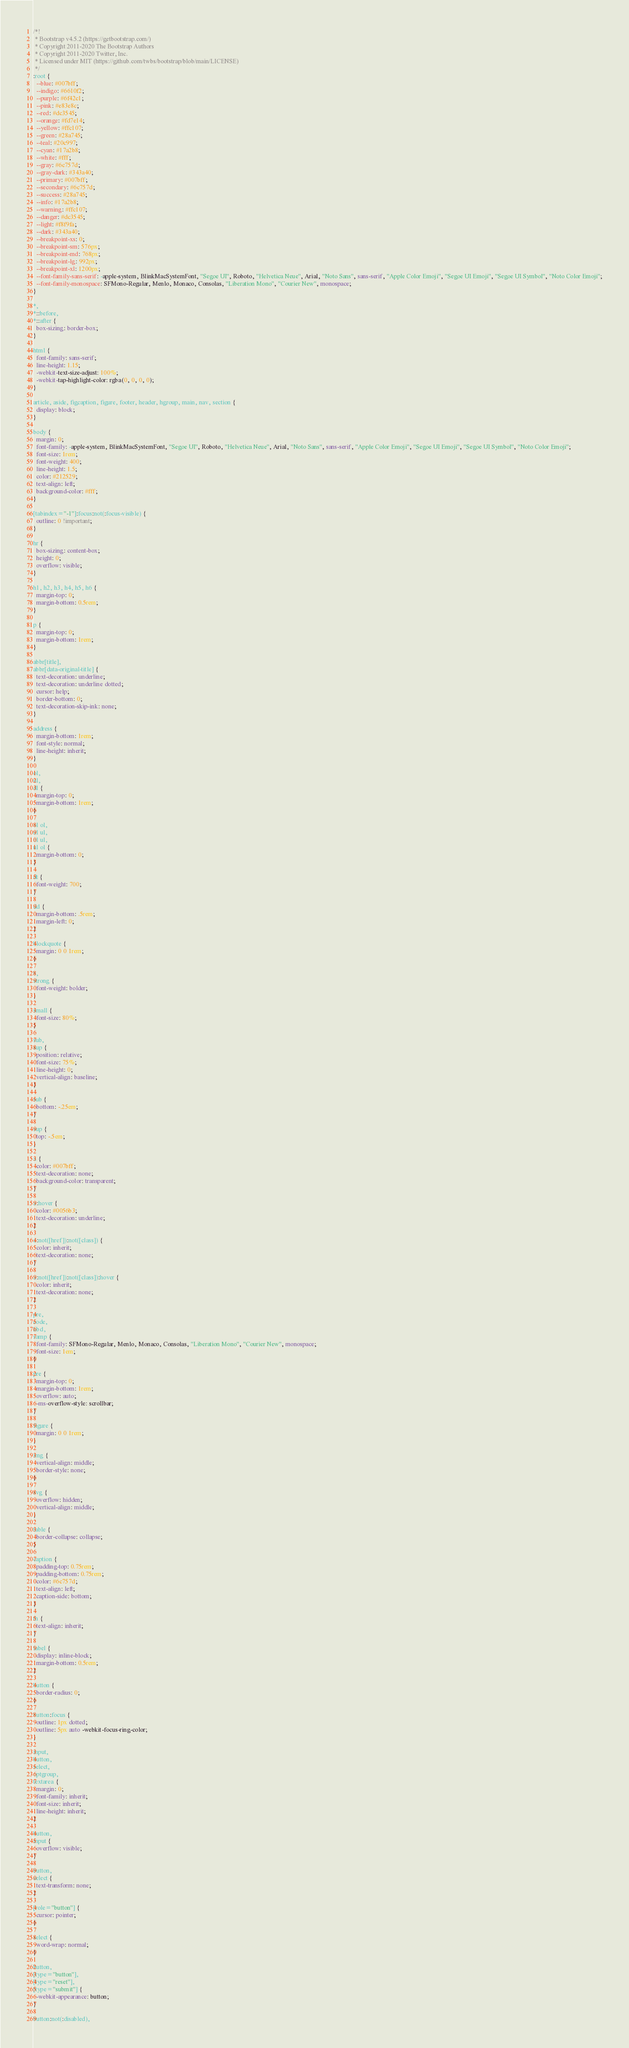<code> <loc_0><loc_0><loc_500><loc_500><_CSS_>/*!
 * Bootstrap v4.5.2 (https://getbootstrap.com/)
 * Copyright 2011-2020 The Bootstrap Authors
 * Copyright 2011-2020 Twitter, Inc.
 * Licensed under MIT (https://github.com/twbs/bootstrap/blob/main/LICENSE)
 */
:root {
  --blue: #007bff;
  --indigo: #6610f2;
  --purple: #6f42c1;
  --pink: #e83e8c;
  --red: #dc3545;
  --orange: #fd7e14;
  --yellow: #ffc107;
  --green: #28a745;
  --teal: #20c997;
  --cyan: #17a2b8;
  --white: #fff;
  --gray: #6c757d;
  --gray-dark: #343a40;
  --primary: #007bff;
  --secondary: #6c757d;
  --success: #28a745;
  --info: #17a2b8;
  --warning: #ffc107;
  --danger: #dc3545;
  --light: #f8f9fa;
  --dark: #343a40;
  --breakpoint-xs: 0;
  --breakpoint-sm: 576px;
  --breakpoint-md: 768px;
  --breakpoint-lg: 992px;
  --breakpoint-xl: 1200px;
  --font-family-sans-serif: -apple-system, BlinkMacSystemFont, "Segoe UI", Roboto, "Helvetica Neue", Arial, "Noto Sans", sans-serif, "Apple Color Emoji", "Segoe UI Emoji", "Segoe UI Symbol", "Noto Color Emoji";
  --font-family-monospace: SFMono-Regular, Menlo, Monaco, Consolas, "Liberation Mono", "Courier New", monospace;
}

*,
*::before,
*::after {
  box-sizing: border-box;
}

html {
  font-family: sans-serif;
  line-height: 1.15;
  -webkit-text-size-adjust: 100%;
  -webkit-tap-highlight-color: rgba(0, 0, 0, 0);
}

article, aside, figcaption, figure, footer, header, hgroup, main, nav, section {
  display: block;
}

body {
  margin: 0;
  font-family: -apple-system, BlinkMacSystemFont, "Segoe UI", Roboto, "Helvetica Neue", Arial, "Noto Sans", sans-serif, "Apple Color Emoji", "Segoe UI Emoji", "Segoe UI Symbol", "Noto Color Emoji";
  font-size: 1rem;
  font-weight: 400;
  line-height: 1.5;
  color: #212529;
  text-align: left;
  background-color: #fff;
}

[tabindex="-1"]:focus:not(:focus-visible) {
  outline: 0 !important;
}

hr {
  box-sizing: content-box;
  height: 0;
  overflow: visible;
}

h1, h2, h3, h4, h5, h6 {
  margin-top: 0;
  margin-bottom: 0.5rem;
}

p {
  margin-top: 0;
  margin-bottom: 1rem;
}

abbr[title],
abbr[data-original-title] {
  text-decoration: underline;
  text-decoration: underline dotted;
  cursor: help;
  border-bottom: 0;
  text-decoration-skip-ink: none;
}

address {
  margin-bottom: 1rem;
  font-style: normal;
  line-height: inherit;
}

ol,
ul,
dl {
  margin-top: 0;
  margin-bottom: 1rem;
}

ol ol,
ul ul,
ol ul,
ul ol {
  margin-bottom: 0;
}

dt {
  font-weight: 700;
}

dd {
  margin-bottom: .5rem;
  margin-left: 0;
}

blockquote {
  margin: 0 0 1rem;
}

b,
strong {
  font-weight: bolder;
}

small {
  font-size: 80%;
}

sub,
sup {
  position: relative;
  font-size: 75%;
  line-height: 0;
  vertical-align: baseline;
}

sub {
  bottom: -.25em;
}

sup {
  top: -.5em;
}

a {
  color: #007bff;
  text-decoration: none;
  background-color: transparent;
}

a:hover {
  color: #0056b3;
  text-decoration: underline;
}

a:not([href]):not([class]) {
  color: inherit;
  text-decoration: none;
}

a:not([href]):not([class]):hover {
  color: inherit;
  text-decoration: none;
}

pre,
code,
kbd,
samp {
  font-family: SFMono-Regular, Menlo, Monaco, Consolas, "Liberation Mono", "Courier New", monospace;
  font-size: 1em;
}

pre {
  margin-top: 0;
  margin-bottom: 1rem;
  overflow: auto;
  -ms-overflow-style: scrollbar;
}

figure {
  margin: 0 0 1rem;
}

img {
  vertical-align: middle;
  border-style: none;
}

svg {
  overflow: hidden;
  vertical-align: middle;
}

table {
  border-collapse: collapse;
}

caption {
  padding-top: 0.75rem;
  padding-bottom: 0.75rem;
  color: #6c757d;
  text-align: left;
  caption-side: bottom;
}

th {
  text-align: inherit;
}

label {
  display: inline-block;
  margin-bottom: 0.5rem;
}

button {
  border-radius: 0;
}

button:focus {
  outline: 1px dotted;
  outline: 5px auto -webkit-focus-ring-color;
}

input,
button,
select,
optgroup,
textarea {
  margin: 0;
  font-family: inherit;
  font-size: inherit;
  line-height: inherit;
}

button,
input {
  overflow: visible;
}

button,
select {
  text-transform: none;
}

[role="button"] {
  cursor: pointer;
}

select {
  word-wrap: normal;
}

button,
[type="button"],
[type="reset"],
[type="submit"] {
  -webkit-appearance: button;
}

button:not(:disabled),</code> 